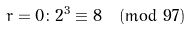<formula> <loc_0><loc_0><loc_500><loc_500>r = 0 \colon 2 ^ { 3 } \equiv 8 { \pmod { 9 7 } }</formula> 